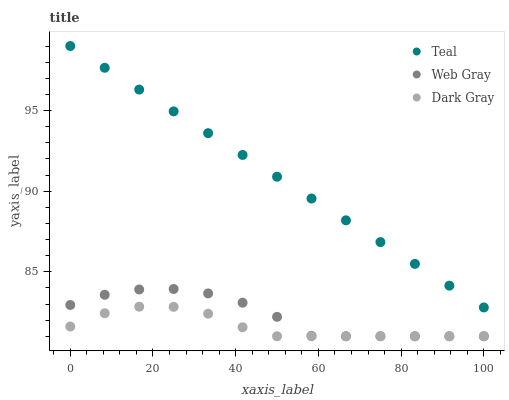Does Dark Gray have the minimum area under the curve?
Answer yes or no. Yes. Does Teal have the maximum area under the curve?
Answer yes or no. Yes. Does Web Gray have the minimum area under the curve?
Answer yes or no. No. Does Web Gray have the maximum area under the curve?
Answer yes or no. No. Is Teal the smoothest?
Answer yes or no. Yes. Is Web Gray the roughest?
Answer yes or no. Yes. Is Web Gray the smoothest?
Answer yes or no. No. Is Teal the roughest?
Answer yes or no. No. Does Dark Gray have the lowest value?
Answer yes or no. Yes. Does Teal have the lowest value?
Answer yes or no. No. Does Teal have the highest value?
Answer yes or no. Yes. Does Web Gray have the highest value?
Answer yes or no. No. Is Dark Gray less than Teal?
Answer yes or no. Yes. Is Teal greater than Dark Gray?
Answer yes or no. Yes. Does Web Gray intersect Dark Gray?
Answer yes or no. Yes. Is Web Gray less than Dark Gray?
Answer yes or no. No. Is Web Gray greater than Dark Gray?
Answer yes or no. No. Does Dark Gray intersect Teal?
Answer yes or no. No. 